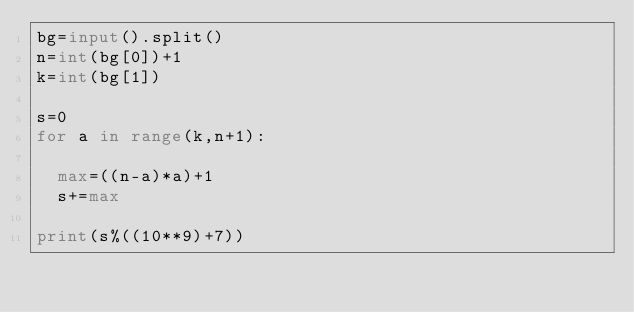Convert code to text. <code><loc_0><loc_0><loc_500><loc_500><_Python_>bg=input().split()
n=int(bg[0])+1
k=int(bg[1])

s=0
for a in range(k,n+1):
  
  max=((n-a)*a)+1
  s+=max
  
print(s%((10**9)+7))</code> 